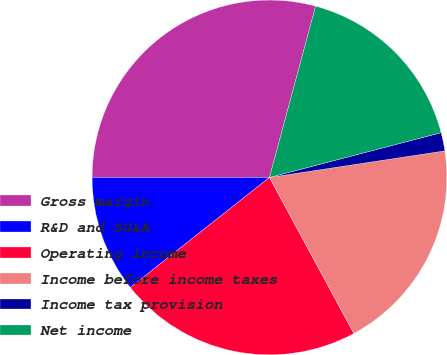Convert chart. <chart><loc_0><loc_0><loc_500><loc_500><pie_chart><fcel>Gross margin<fcel>R&D and SG&A<fcel>Operating income<fcel>Income before income taxes<fcel>Income tax provision<fcel>Net income<nl><fcel>29.19%<fcel>10.65%<fcel>22.25%<fcel>19.5%<fcel>1.67%<fcel>16.75%<nl></chart> 